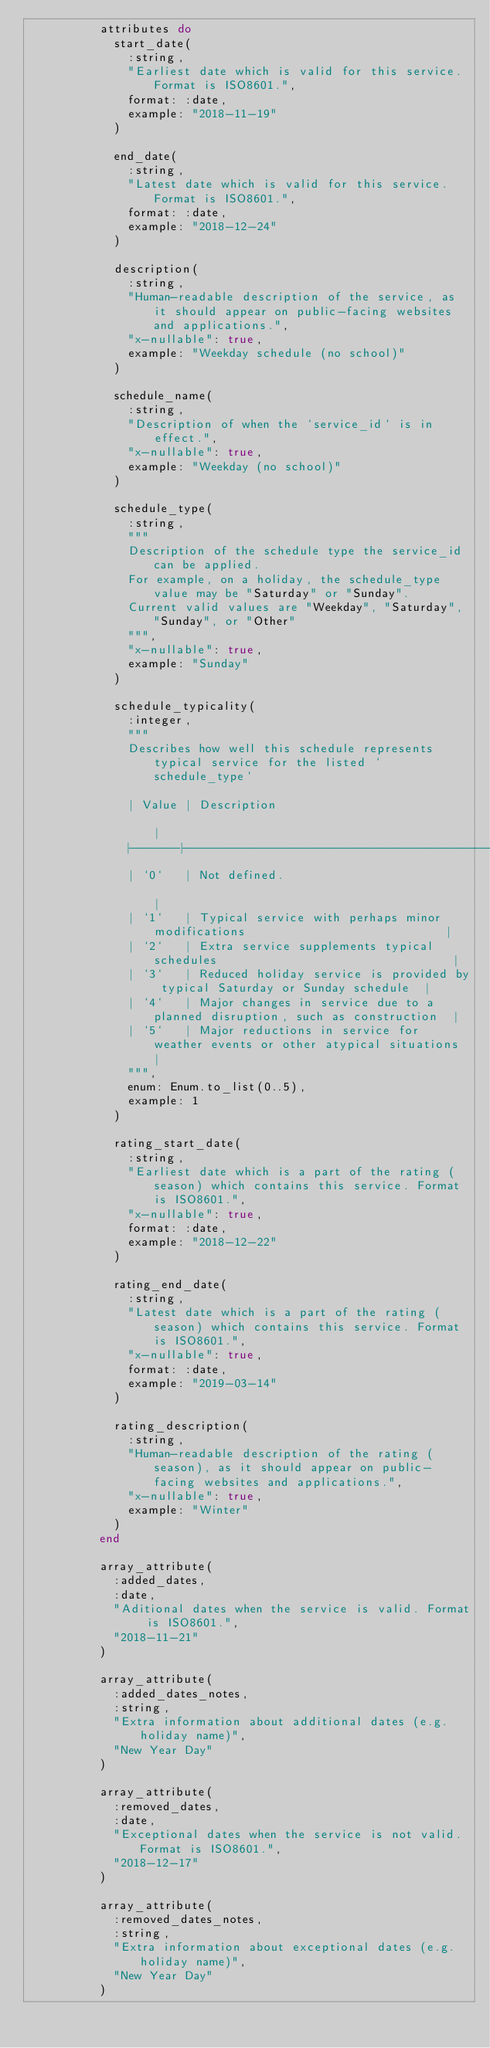Convert code to text. <code><loc_0><loc_0><loc_500><loc_500><_Elixir_>          attributes do
            start_date(
              :string,
              "Earliest date which is valid for this service. Format is ISO8601.",
              format: :date,
              example: "2018-11-19"
            )

            end_date(
              :string,
              "Latest date which is valid for this service. Format is ISO8601.",
              format: :date,
              example: "2018-12-24"
            )

            description(
              :string,
              "Human-readable description of the service, as it should appear on public-facing websites and applications.",
              "x-nullable": true,
              example: "Weekday schedule (no school)"
            )

            schedule_name(
              :string,
              "Description of when the `service_id` is in effect.",
              "x-nullable": true,
              example: "Weekday (no school)"
            )

            schedule_type(
              :string,
              """
              Description of the schedule type the service_id can be applied.
              For example, on a holiday, the schedule_type value may be "Saturday" or "Sunday".
              Current valid values are "Weekday", "Saturday", "Sunday", or "Other"
              """,
              "x-nullable": true,
              example: "Sunday"
            )

            schedule_typicality(
              :integer,
              """
              Describes how well this schedule represents typical service for the listed `schedule_type`

              | Value | Description                                                                 |
              |-------|-----------------------------------------------------------------------------|
              | `0`   | Not defined.                                                                |
              | `1`   | Typical service with perhaps minor modifications                            |
              | `2`   | Extra service supplements typical schedules                                 |
              | `3`   | Reduced holiday service is provided by typical Saturday or Sunday schedule  |
              | `4`   | Major changes in service due to a planned disruption, such as construction  |
              | `5`   | Major reductions in service for weather events or other atypical situations |
              """,
              enum: Enum.to_list(0..5),
              example: 1
            )

            rating_start_date(
              :string,
              "Earliest date which is a part of the rating (season) which contains this service. Format is ISO8601.",
              "x-nullable": true,
              format: :date,
              example: "2018-12-22"
            )

            rating_end_date(
              :string,
              "Latest date which is a part of the rating (season) which contains this service. Format is ISO8601.",
              "x-nullable": true,
              format: :date,
              example: "2019-03-14"
            )

            rating_description(
              :string,
              "Human-readable description of the rating (season), as it should appear on public-facing websites and applications.",
              "x-nullable": true,
              example: "Winter"
            )
          end

          array_attribute(
            :added_dates,
            :date,
            "Aditional dates when the service is valid. Format is ISO8601.",
            "2018-11-21"
          )

          array_attribute(
            :added_dates_notes,
            :string,
            "Extra information about additional dates (e.g. holiday name)",
            "New Year Day"
          )

          array_attribute(
            :removed_dates,
            :date,
            "Exceptional dates when the service is not valid. Format is ISO8601.",
            "2018-12-17"
          )

          array_attribute(
            :removed_dates_notes,
            :string,
            "Extra information about exceptional dates (e.g. holiday name)",
            "New Year Day"
          )
</code> 